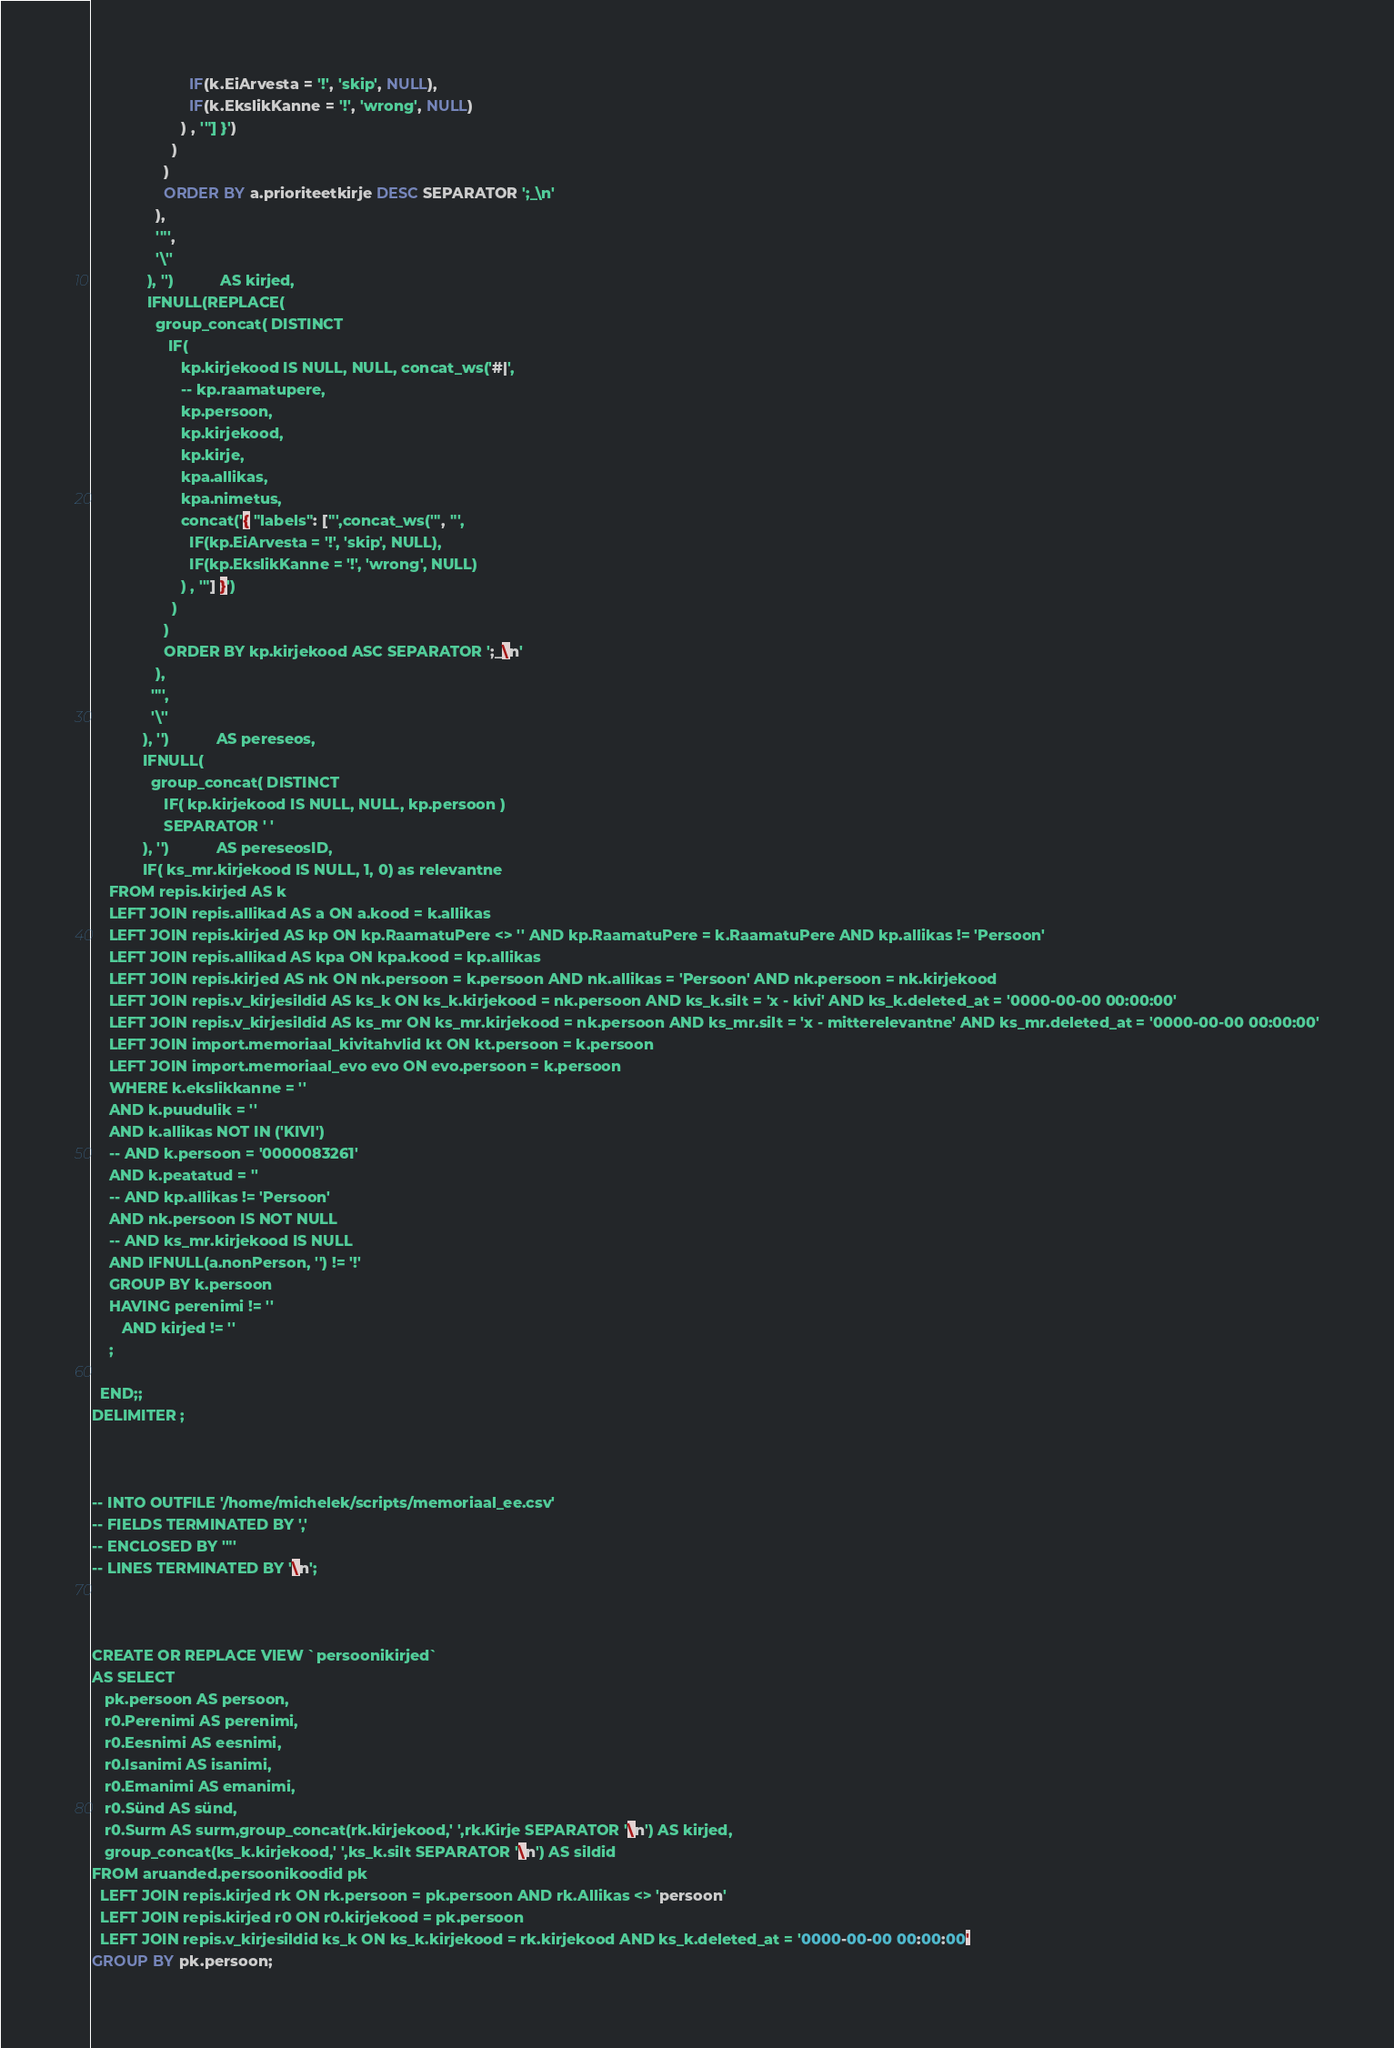<code> <loc_0><loc_0><loc_500><loc_500><_SQL_>                       IF(k.EiArvesta = '!', 'skip', NULL),
                       IF(k.EkslikKanne = '!', 'wrong', NULL)
                     ) , '"] }')
                   )
                 )
                 ORDER BY a.prioriteetkirje DESC SEPARATOR ';_\n'
               ),
               '"',
               '\''
             ), '')           AS kirjed,
             IFNULL(REPLACE(
               group_concat( DISTINCT
                  IF(
                     kp.kirjekood IS NULL, NULL, concat_ws('#|',
                     -- kp.raamatupere,
                     kp.persoon,
                     kp.kirjekood,
                     kp.kirje,
                     kpa.allikas,
                     kpa.nimetus,
                     concat('{ "labels": ["',concat_ws('", "',
                       IF(kp.EiArvesta = '!', 'skip', NULL),
                       IF(kp.EkslikKanne = '!', 'wrong', NULL)
                     ) , '"] }')
                   )
                 )
                 ORDER BY kp.kirjekood ASC SEPARATOR ';_\n'
               ),
              '"',
              '\''
            ), '')           AS pereseos,
            IFNULL(
              group_concat( DISTINCT
                 IF( kp.kirjekood IS NULL, NULL, kp.persoon )
                 SEPARATOR ' '
            ), '')           AS pereseosID,
            IF( ks_mr.kirjekood IS NULL, 1, 0) as relevantne
    FROM repis.kirjed AS k
    LEFT JOIN repis.allikad AS a ON a.kood = k.allikas
    LEFT JOIN repis.kirjed AS kp ON kp.RaamatuPere <> '' AND kp.RaamatuPere = k.RaamatuPere AND kp.allikas != 'Persoon'
    LEFT JOIN repis.allikad AS kpa ON kpa.kood = kp.allikas
    LEFT JOIN repis.kirjed AS nk ON nk.persoon = k.persoon AND nk.allikas = 'Persoon' AND nk.persoon = nk.kirjekood
    LEFT JOIN repis.v_kirjesildid AS ks_k ON ks_k.kirjekood = nk.persoon AND ks_k.silt = 'x - kivi' AND ks_k.deleted_at = '0000-00-00 00:00:00'
    LEFT JOIN repis.v_kirjesildid AS ks_mr ON ks_mr.kirjekood = nk.persoon AND ks_mr.silt = 'x - mitterelevantne' AND ks_mr.deleted_at = '0000-00-00 00:00:00'
    LEFT JOIN import.memoriaal_kivitahvlid kt ON kt.persoon = k.persoon
    LEFT JOIN import.memoriaal_evo evo ON evo.persoon = k.persoon
    WHERE k.ekslikkanne = ''
    AND k.puudulik = ''
    AND k.allikas NOT IN ('KIVI')
    -- AND k.persoon = '0000083261'
    AND k.peatatud = ''
    -- AND kp.allikas != 'Persoon'
    AND nk.persoon IS NOT NULL
    -- AND ks_mr.kirjekood IS NULL
    AND IFNULL(a.nonPerson, '') != '!'
    GROUP BY k.persoon
    HAVING perenimi != ''
       AND kirjed != ''
    ;

  END;;
DELIMITER ;



-- INTO OUTFILE '/home/michelek/scripts/memoriaal_ee.csv'
-- FIELDS TERMINATED BY ','
-- ENCLOSED BY '"'
-- LINES TERMINATED BY '\n';



CREATE OR REPLACE VIEW `persoonikirjed`
AS SELECT
   pk.persoon AS persoon,
   r0.Perenimi AS perenimi,
   r0.Eesnimi AS eesnimi,
   r0.Isanimi AS isanimi,
   r0.Emanimi AS emanimi,
   r0.Sünd AS sünd,
   r0.Surm AS surm,group_concat(rk.kirjekood,' ',rk.Kirje SEPARATOR '\n') AS kirjed,
   group_concat(ks_k.kirjekood,' ',ks_k.silt SEPARATOR '\n') AS sildid
FROM aruanded.persoonikoodid pk
  LEFT JOIN repis.kirjed rk ON rk.persoon = pk.persoon AND rk.Allikas <> 'persoon'
  LEFT JOIN repis.kirjed r0 ON r0.kirjekood = pk.persoon
  LEFT JOIN repis.v_kirjesildid ks_k ON ks_k.kirjekood = rk.kirjekood AND ks_k.deleted_at = '0000-00-00 00:00:00'
GROUP BY pk.persoon;
</code> 